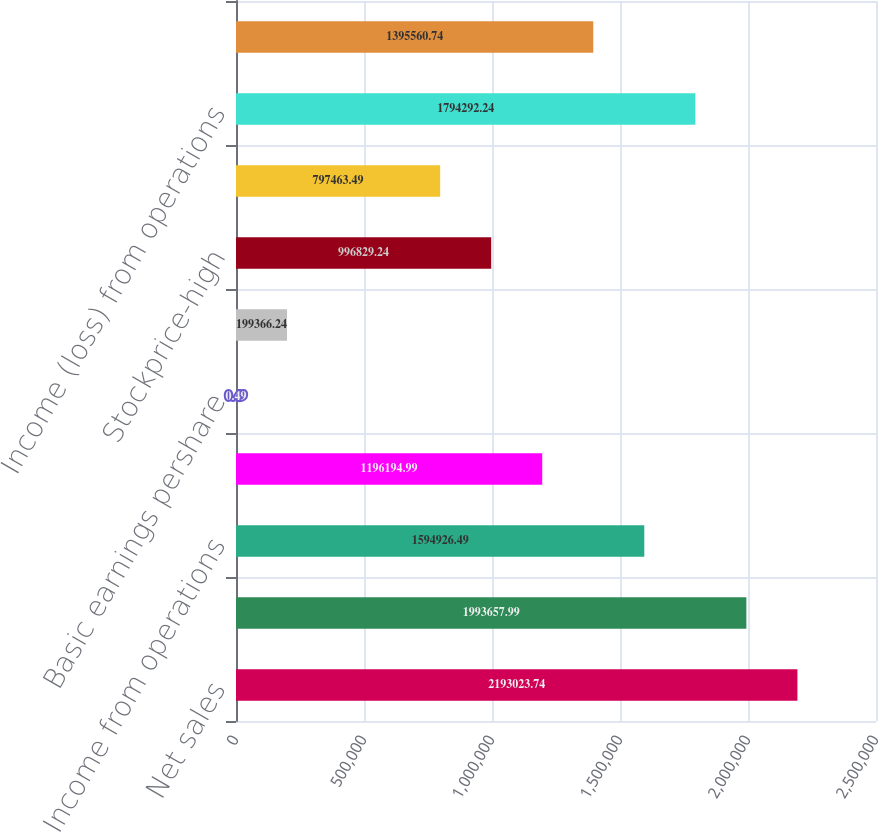Convert chart. <chart><loc_0><loc_0><loc_500><loc_500><bar_chart><fcel>Net sales<fcel>Grossprofit<fcel>Income from operations<fcel>Net income<fcel>Basic earnings pershare<fcel>Diluted earnings pershare<fcel>Stockprice-high<fcel>Stockprice-low<fcel>Income (loss) from operations<fcel>Net income (loss)<nl><fcel>2.19302e+06<fcel>1.99366e+06<fcel>1.59493e+06<fcel>1.19619e+06<fcel>0.49<fcel>199366<fcel>996829<fcel>797463<fcel>1.79429e+06<fcel>1.39556e+06<nl></chart> 